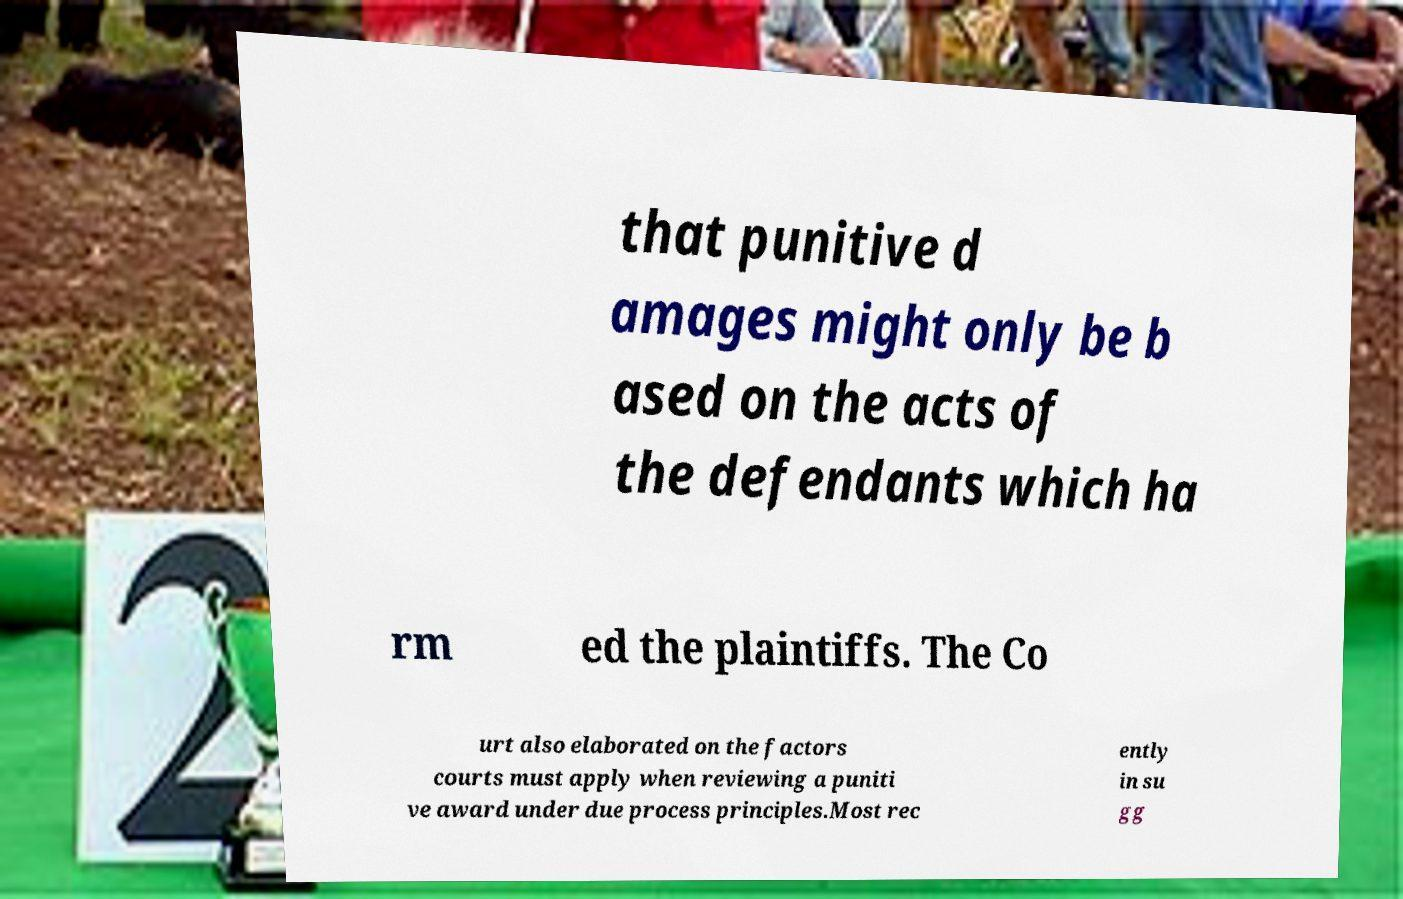Could you extract and type out the text from this image? that punitive d amages might only be b ased on the acts of the defendants which ha rm ed the plaintiffs. The Co urt also elaborated on the factors courts must apply when reviewing a puniti ve award under due process principles.Most rec ently in su gg 